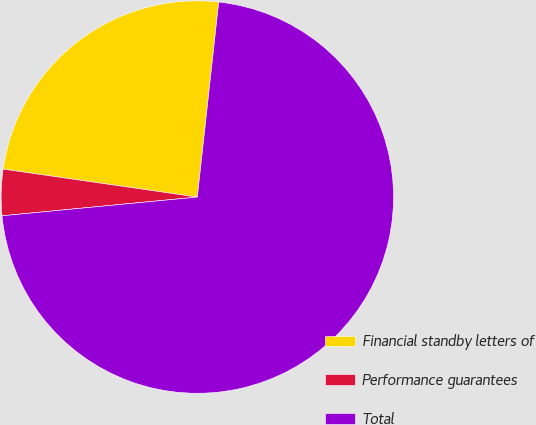<chart> <loc_0><loc_0><loc_500><loc_500><pie_chart><fcel>Financial standby letters of<fcel>Performance guarantees<fcel>Total<nl><fcel>24.46%<fcel>3.8%<fcel>71.74%<nl></chart> 